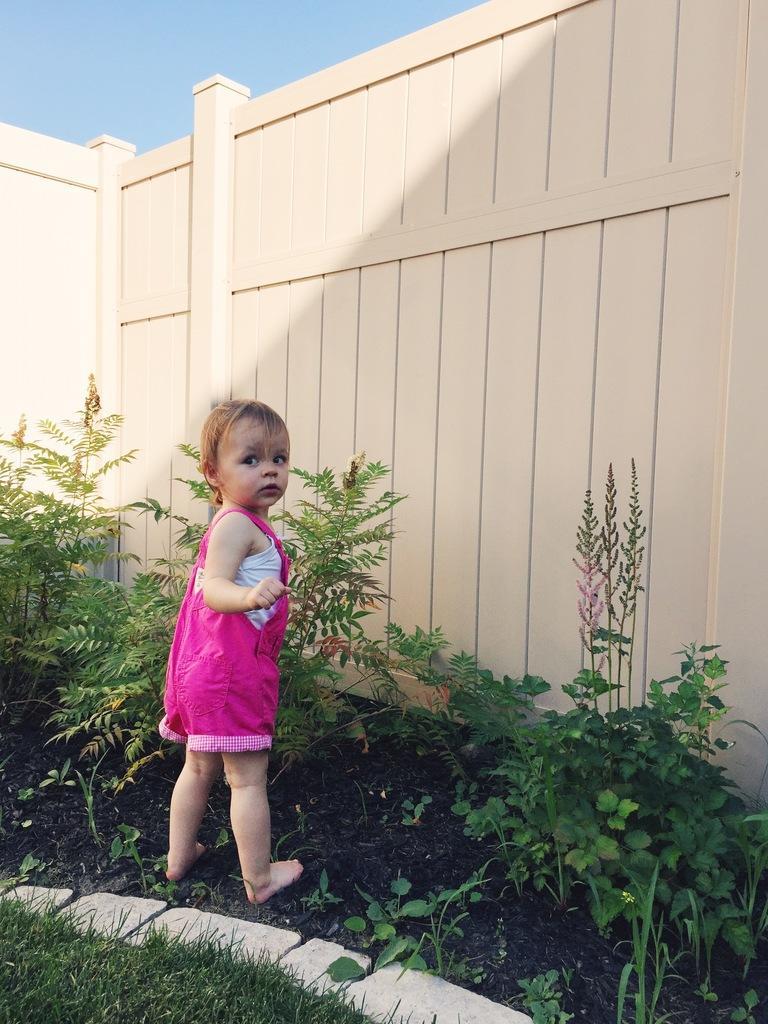Can you describe this image briefly? In the image there is a baby in pink dress standing on grass land with plants in front of her followed by a fence and above its sky. 